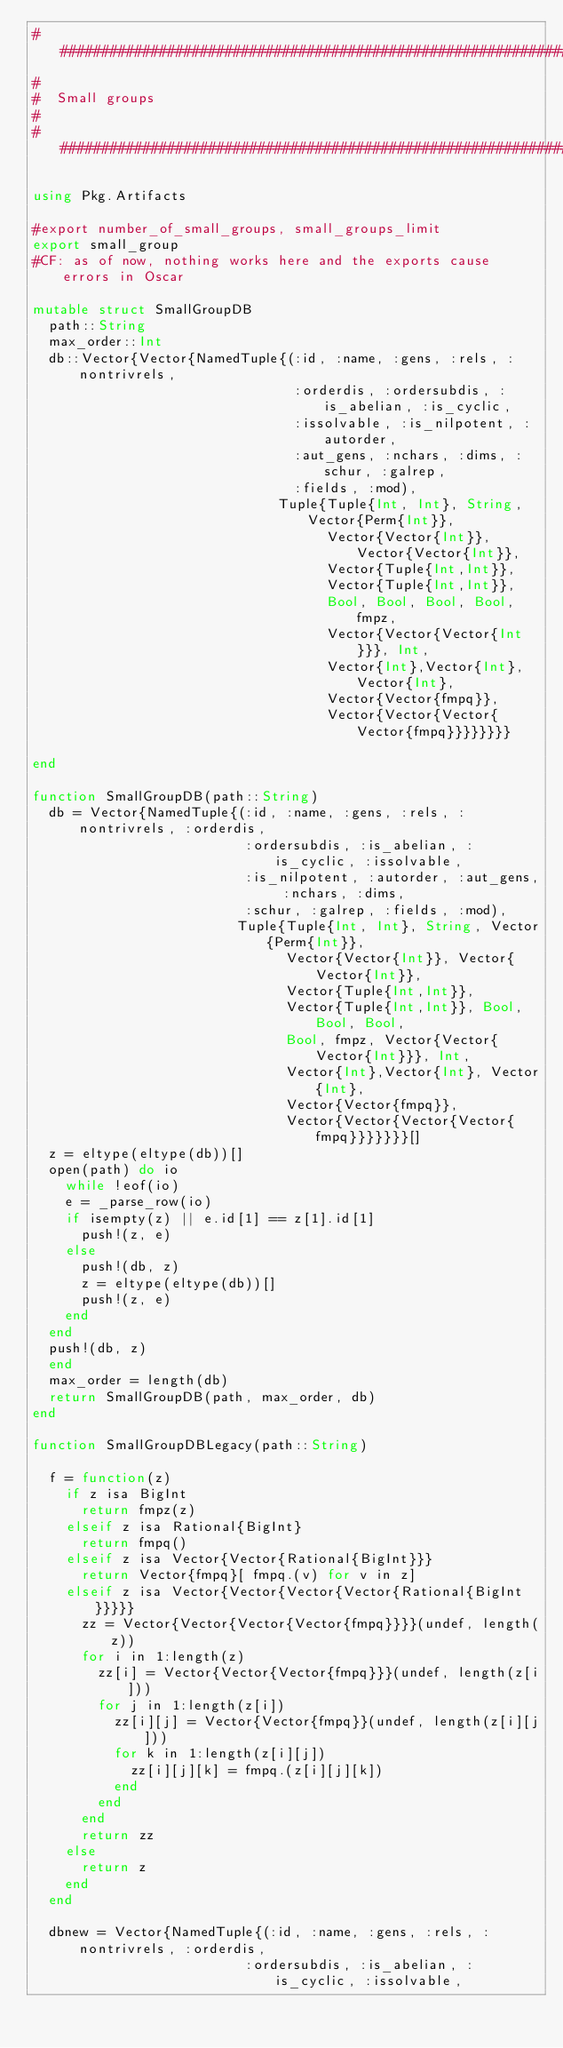<code> <loc_0><loc_0><loc_500><loc_500><_Julia_>################################################################################
#
#  Small groups
#
################################################################################

using Pkg.Artifacts

#export number_of_small_groups, small_groups_limit
export small_group
#CF: as of now, nothing works here and the exports cause errors in Oscar

mutable struct SmallGroupDB
  path::String
  max_order::Int
  db::Vector{Vector{NamedTuple{(:id, :name, :gens, :rels, :nontrivrels,
                                :orderdis, :ordersubdis, :is_abelian, :is_cyclic,
                                :issolvable, :is_nilpotent, :autorder,
                                :aut_gens, :nchars, :dims, :schur, :galrep,
                                :fields, :mod),
                              Tuple{Tuple{Int, Int}, String, Vector{Perm{Int}},
                                    Vector{Vector{Int}}, Vector{Vector{Int}},
                                    Vector{Tuple{Int,Int}},
                                    Vector{Tuple{Int,Int}},
                                    Bool, Bool, Bool, Bool, fmpz,
                                    Vector{Vector{Vector{Int}}}, Int,
                                    Vector{Int},Vector{Int}, Vector{Int},
                                    Vector{Vector{fmpq}},
                                    Vector{Vector{Vector{Vector{fmpq}}}}}}}}

end

function SmallGroupDB(path::String)
  db = Vector{NamedTuple{(:id, :name, :gens, :rels, :nontrivrels, :orderdis,
                          :ordersubdis, :is_abelian, :is_cyclic, :issolvable,
                          :is_nilpotent, :autorder, :aut_gens, :nchars, :dims,
                          :schur, :galrep, :fields, :mod),
                         Tuple{Tuple{Int, Int}, String, Vector{Perm{Int}},
                               Vector{Vector{Int}}, Vector{Vector{Int}},
                               Vector{Tuple{Int,Int}},
                               Vector{Tuple{Int,Int}}, Bool, Bool, Bool,
                               Bool, fmpz, Vector{Vector{Vector{Int}}}, Int,
                               Vector{Int},Vector{Int}, Vector{Int},
                               Vector{Vector{fmpq}},
                               Vector{Vector{Vector{Vector{fmpq}}}}}}}[]
  z = eltype(eltype(db))[]
  open(path) do io
    while !eof(io)
    e = _parse_row(io)
    if isempty(z) || e.id[1] == z[1].id[1]
      push!(z, e)
    else
      push!(db, z)
      z = eltype(eltype(db))[]
      push!(z, e)
    end
  end
  push!(db, z)
  end
  max_order = length(db)
  return SmallGroupDB(path, max_order, db)
end

function SmallGroupDBLegacy(path::String)

  f = function(z)
    if z isa BigInt
      return fmpz(z)
    elseif z isa Rational{BigInt}
      return fmpq()
    elseif z isa Vector{Vector{Rational{BigInt}}}
      return Vector{fmpq}[ fmpq.(v) for v in z]
    elseif z isa Vector{Vector{Vector{Vector{Rational{BigInt}}}}}
      zz = Vector{Vector{Vector{Vector{fmpq}}}}(undef, length(z))
      for i in 1:length(z)
        zz[i] = Vector{Vector{Vector{fmpq}}}(undef, length(z[i]))
        for j in 1:length(z[i])
          zz[i][j] = Vector{Vector{fmpq}}(undef, length(z[i][j]))
          for k in 1:length(z[i][j])
            zz[i][j][k] = fmpq.(z[i][j][k])
          end
        end
      end
      return zz
    else
      return z
    end
  end

  dbnew = Vector{NamedTuple{(:id, :name, :gens, :rels, :nontrivrels, :orderdis,
                          :ordersubdis, :is_abelian, :is_cyclic, :issolvable,</code> 